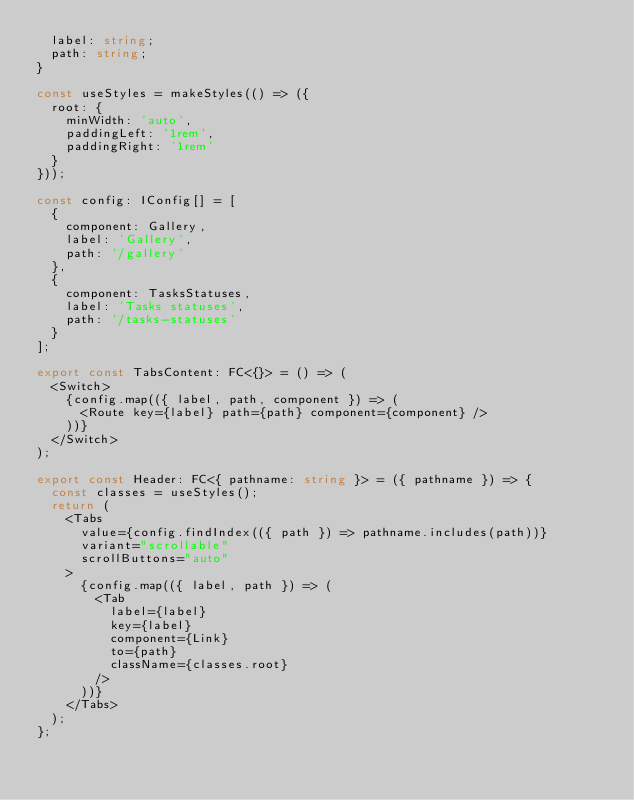Convert code to text. <code><loc_0><loc_0><loc_500><loc_500><_TypeScript_>  label: string;
  path: string;
}

const useStyles = makeStyles(() => ({
  root: {
    minWidth: 'auto',
    paddingLeft: '1rem',
    paddingRight: '1rem'
  }
}));

const config: IConfig[] = [
  {
    component: Gallery,
    label: 'Gallery',
    path: '/gallery'
  },
  {
    component: TasksStatuses,
    label: 'Tasks statuses',
    path: '/tasks-statuses'
  }
];

export const TabsContent: FC<{}> = () => (
  <Switch>
    {config.map(({ label, path, component }) => (
      <Route key={label} path={path} component={component} />
    ))}
  </Switch>
);

export const Header: FC<{ pathname: string }> = ({ pathname }) => {
  const classes = useStyles();
  return (
    <Tabs
      value={config.findIndex(({ path }) => pathname.includes(path))}
      variant="scrollable"
      scrollButtons="auto"
    >
      {config.map(({ label, path }) => (
        <Tab
          label={label}
          key={label}
          component={Link}
          to={path}
          className={classes.root}
        />
      ))}
    </Tabs>
  );
};
</code> 